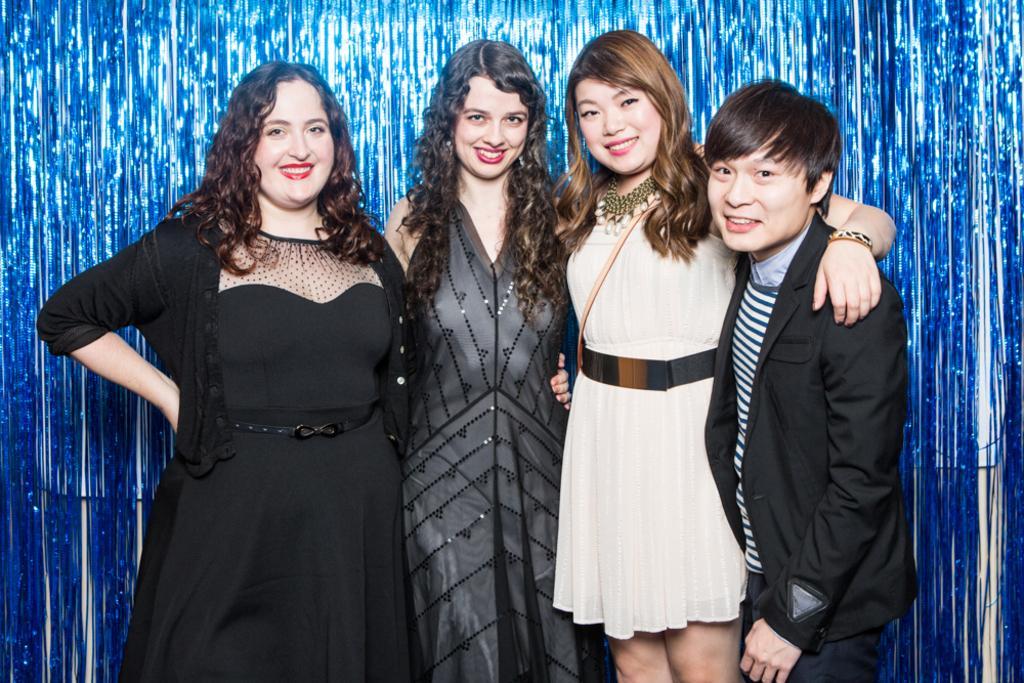Could you give a brief overview of what you see in this image? On the right side a man is standing, he wore black color coat, beside him a beautiful girl is standing, she wore a white color dress, beside her two another girls are smiling. 